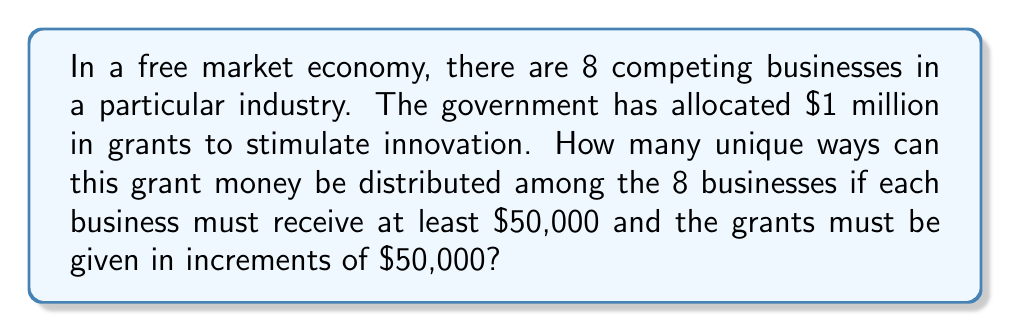Teach me how to tackle this problem. Let's approach this step-by-step:

1) First, we need to determine how many $50,000 increments are in $1 million:
   $\frac{1,000,000}{50,000} = 20$ increments

2) Each business must receive at least one increment (at least $50,000). So, we start by giving each business one increment:
   $8 \times 50,000 = 400,000$

3) This leaves us with $1,000,000 - 400,000 = 600,000$ or 12 increments to distribute.

4) Now, our problem has been reduced to: In how many ways can we distribute 12 identical objects (the remaining increments) among 8 distinct businesses?

5) This is a classic stars and bars problem in combinatorics. The formula for this is:

   $$\binom{n+k-1}{k-1}$$

   where $n$ is the number of identical objects and $k$ is the number of distinct groups.

6) In our case, $n = 12$ and $k = 8$. So we need to calculate:

   $$\binom{12+8-1}{8-1} = \binom{19}{7}$$

7) We can calculate this as:

   $$\binom{19}{7} = \frac{19!}{7!(19-7)!} = \frac{19!}{7!12!}$$

8) Evaluating this:

   $$\frac{19 \times 18 \times 17 \times 16 \times 15 \times 14 \times 13}{7 \times 6 \times 5 \times 4 \times 3 \times 2 \times 1} = 50,388$$

Therefore, there are 50,388 unique ways to distribute the grant money among the 8 businesses.
Answer: 50,388 